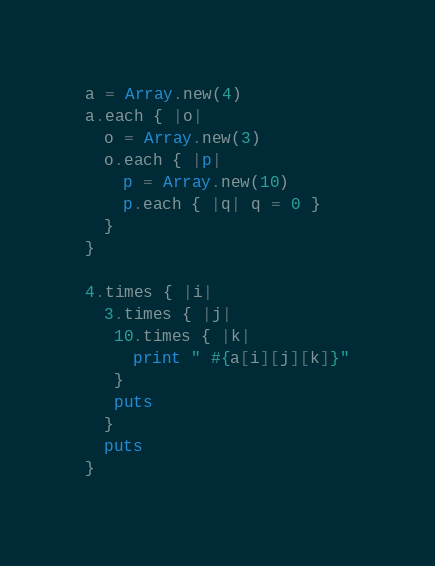<code> <loc_0><loc_0><loc_500><loc_500><_Ruby_>a = Array.new(4)
a.each { |o|
  o = Array.new(3)
  o.each { |p|
    p = Array.new(10)
    p.each { |q| q = 0 }
  }
}

4.times { |i|
  3.times { |j|
   10.times { |k|
     print " #{a[i][j][k]}"
   }
   puts
  }
  puts
}</code> 